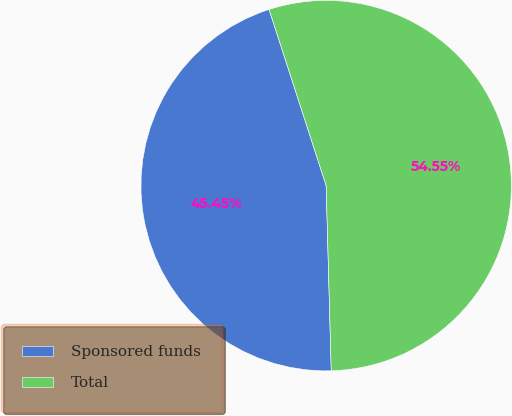Convert chart to OTSL. <chart><loc_0><loc_0><loc_500><loc_500><pie_chart><fcel>Sponsored funds<fcel>Total<nl><fcel>45.45%<fcel>54.55%<nl></chart> 